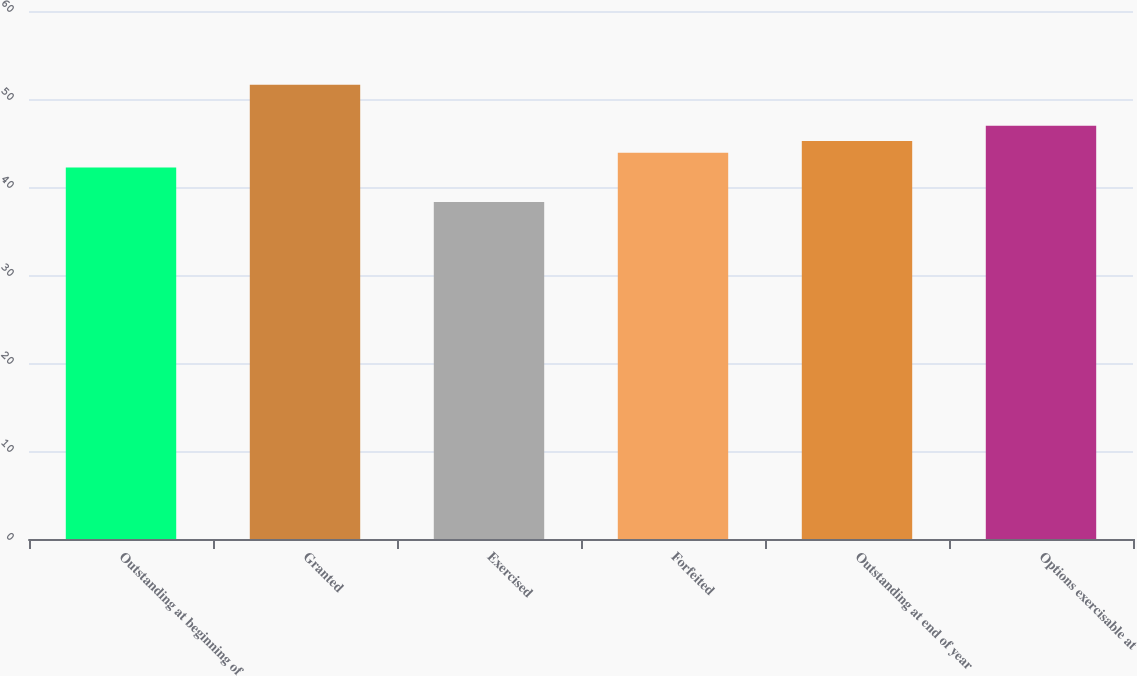Convert chart to OTSL. <chart><loc_0><loc_0><loc_500><loc_500><bar_chart><fcel>Outstanding at beginning of<fcel>Granted<fcel>Exercised<fcel>Forfeited<fcel>Outstanding at end of year<fcel>Options exercisable at<nl><fcel>42.21<fcel>51.62<fcel>38.3<fcel>43.9<fcel>45.23<fcel>46.95<nl></chart> 